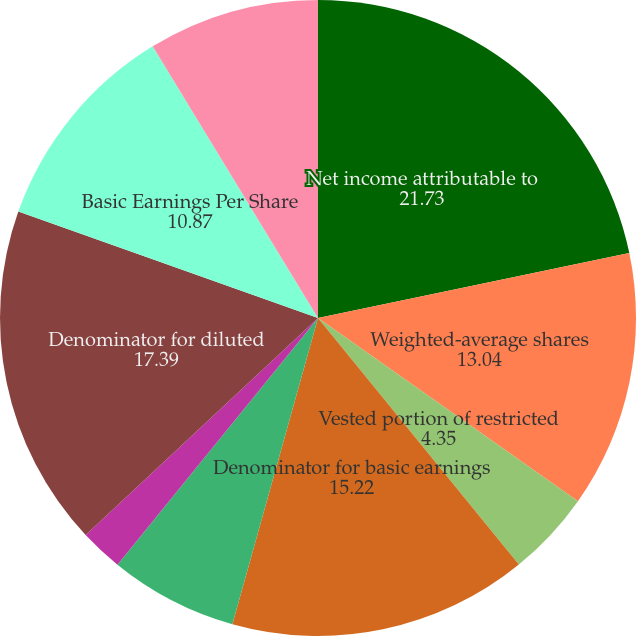Convert chart to OTSL. <chart><loc_0><loc_0><loc_500><loc_500><pie_chart><fcel>Net income attributable to<fcel>Weighted-average shares<fcel>Deferred compensation<fcel>Vested portion of restricted<fcel>Denominator for basic earnings<fcel>Restricted performance units<fcel>Stock options<fcel>Denominator for diluted<fcel>Basic Earnings Per Share<fcel>Diluted Earnings Per Share<nl><fcel>21.73%<fcel>13.04%<fcel>0.0%<fcel>4.35%<fcel>15.22%<fcel>6.52%<fcel>2.18%<fcel>17.39%<fcel>10.87%<fcel>8.7%<nl></chart> 